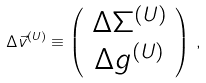Convert formula to latex. <formula><loc_0><loc_0><loc_500><loc_500>\Delta \vec { v } ^ { ( U ) } \equiv \left ( \begin{array} { c } \Delta \Sigma ^ { ( U ) } \\ \Delta g ^ { ( U ) } \\ \end{array} \right ) \, ,</formula> 